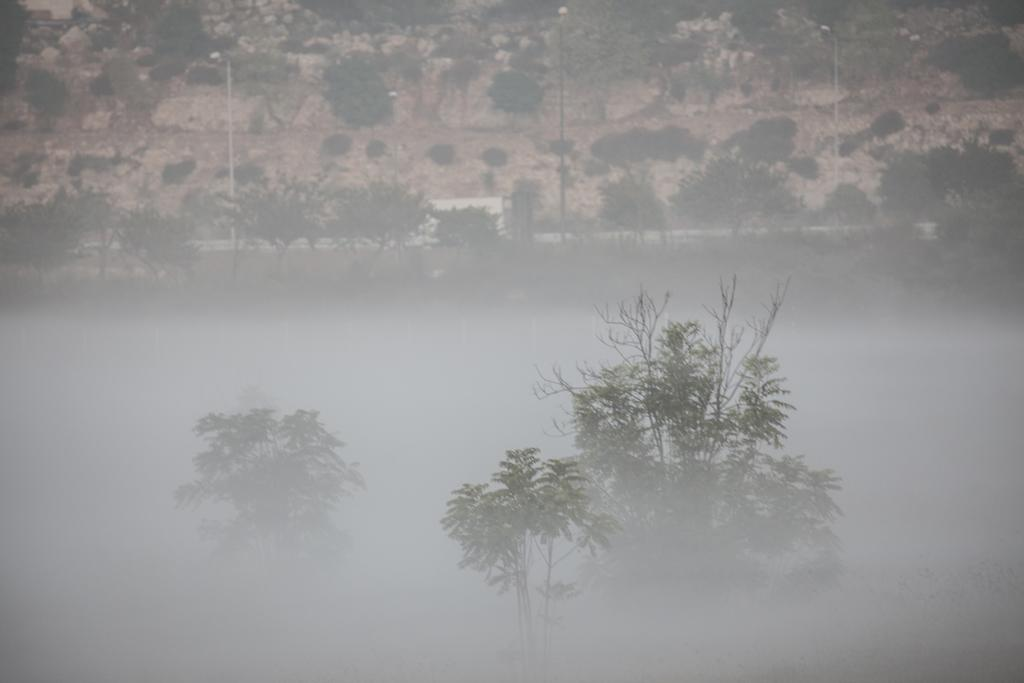What type of vegetation is present on the ground in the image? There are trees on the ground in the image. What structures can be seen in the image? There are poles in the image. How would you describe the clarity of the image? The image is blurry. What type of box can be seen near the trees in the image? There is no box present in the image; it only features trees and poles. Can you tell me which vein is visible in the image? There are no veins visible in the image, as it does not depict any living organisms. 